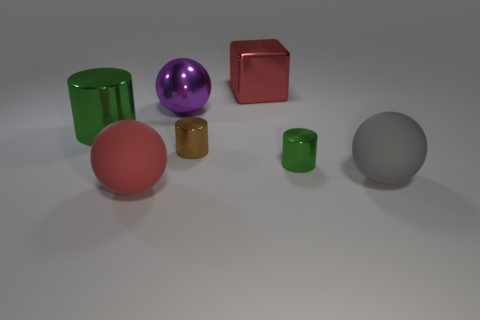Are there any shapes in the image that aren't typical geometric solids? Great observation! All the shapes here appear to be standard geometric solids like spheres, cylinders, and cubes. There are no irregular or complex shapes present. 